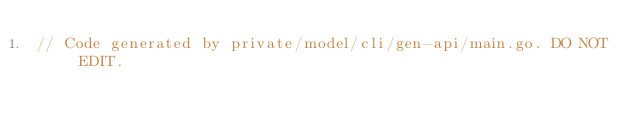<code> <loc_0><loc_0><loc_500><loc_500><_Go_>// Code generated by private/model/cli/gen-api/main.go. DO NOT EDIT.
</code> 